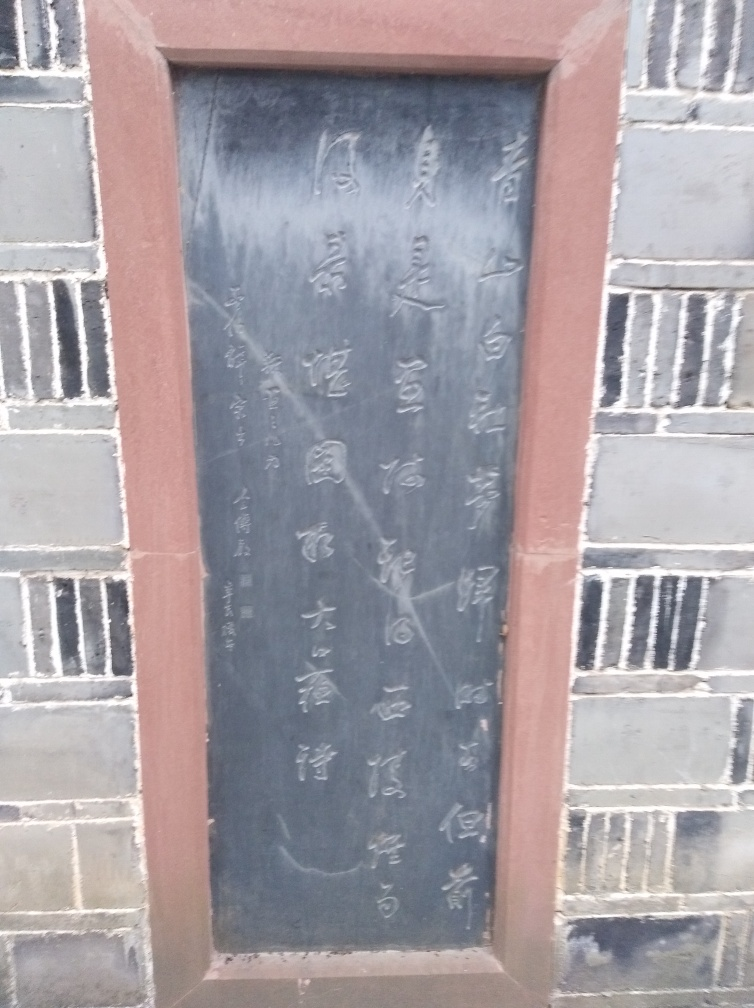Can you tell me more about what's written on this tablet? The image showcases an inscribed stone tablet with characters that appear to be Chinese. Unfortunately, due to the photo's medium clarity, it's challenging to read all the inscriptions clearly. However, they might be conveying historical or cultural information, possibly poetry or commemorating an event. 